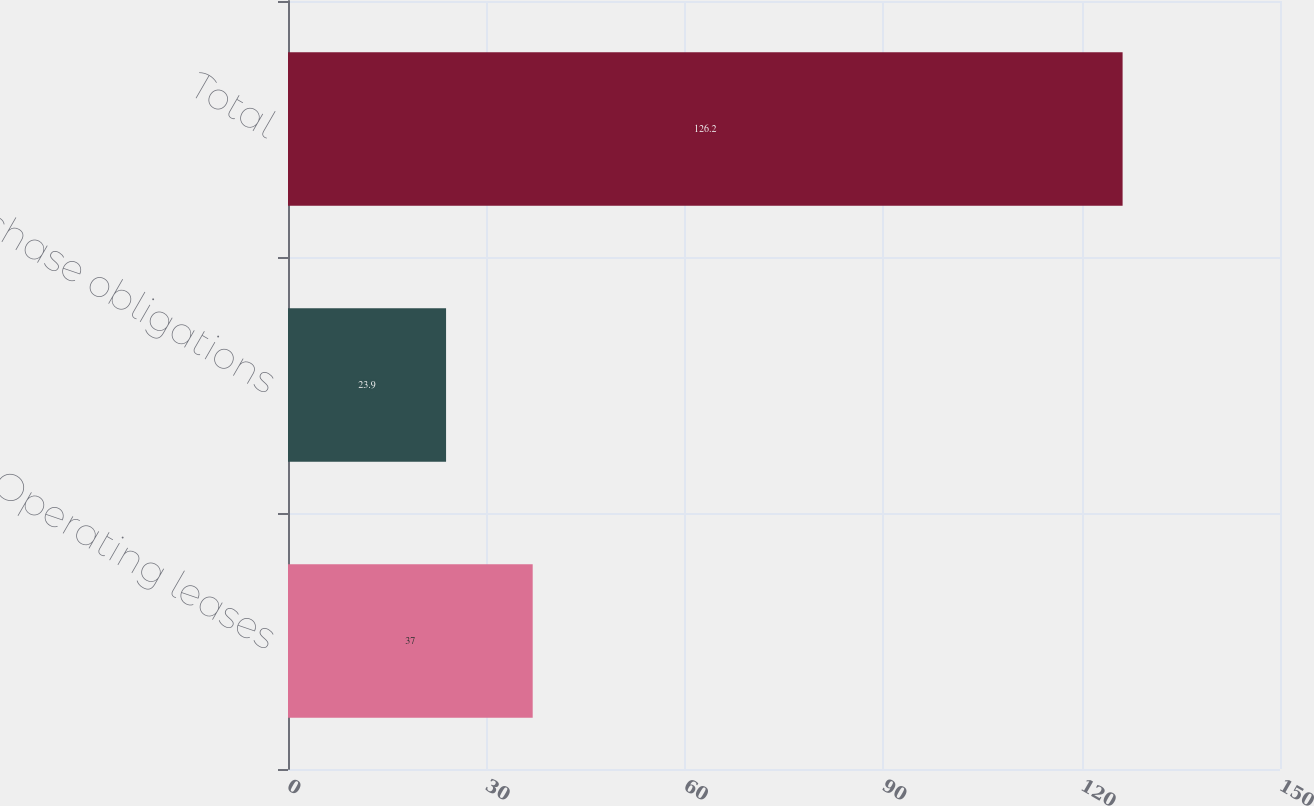<chart> <loc_0><loc_0><loc_500><loc_500><bar_chart><fcel>Operating leases<fcel>Purchase obligations<fcel>Total<nl><fcel>37<fcel>23.9<fcel>126.2<nl></chart> 